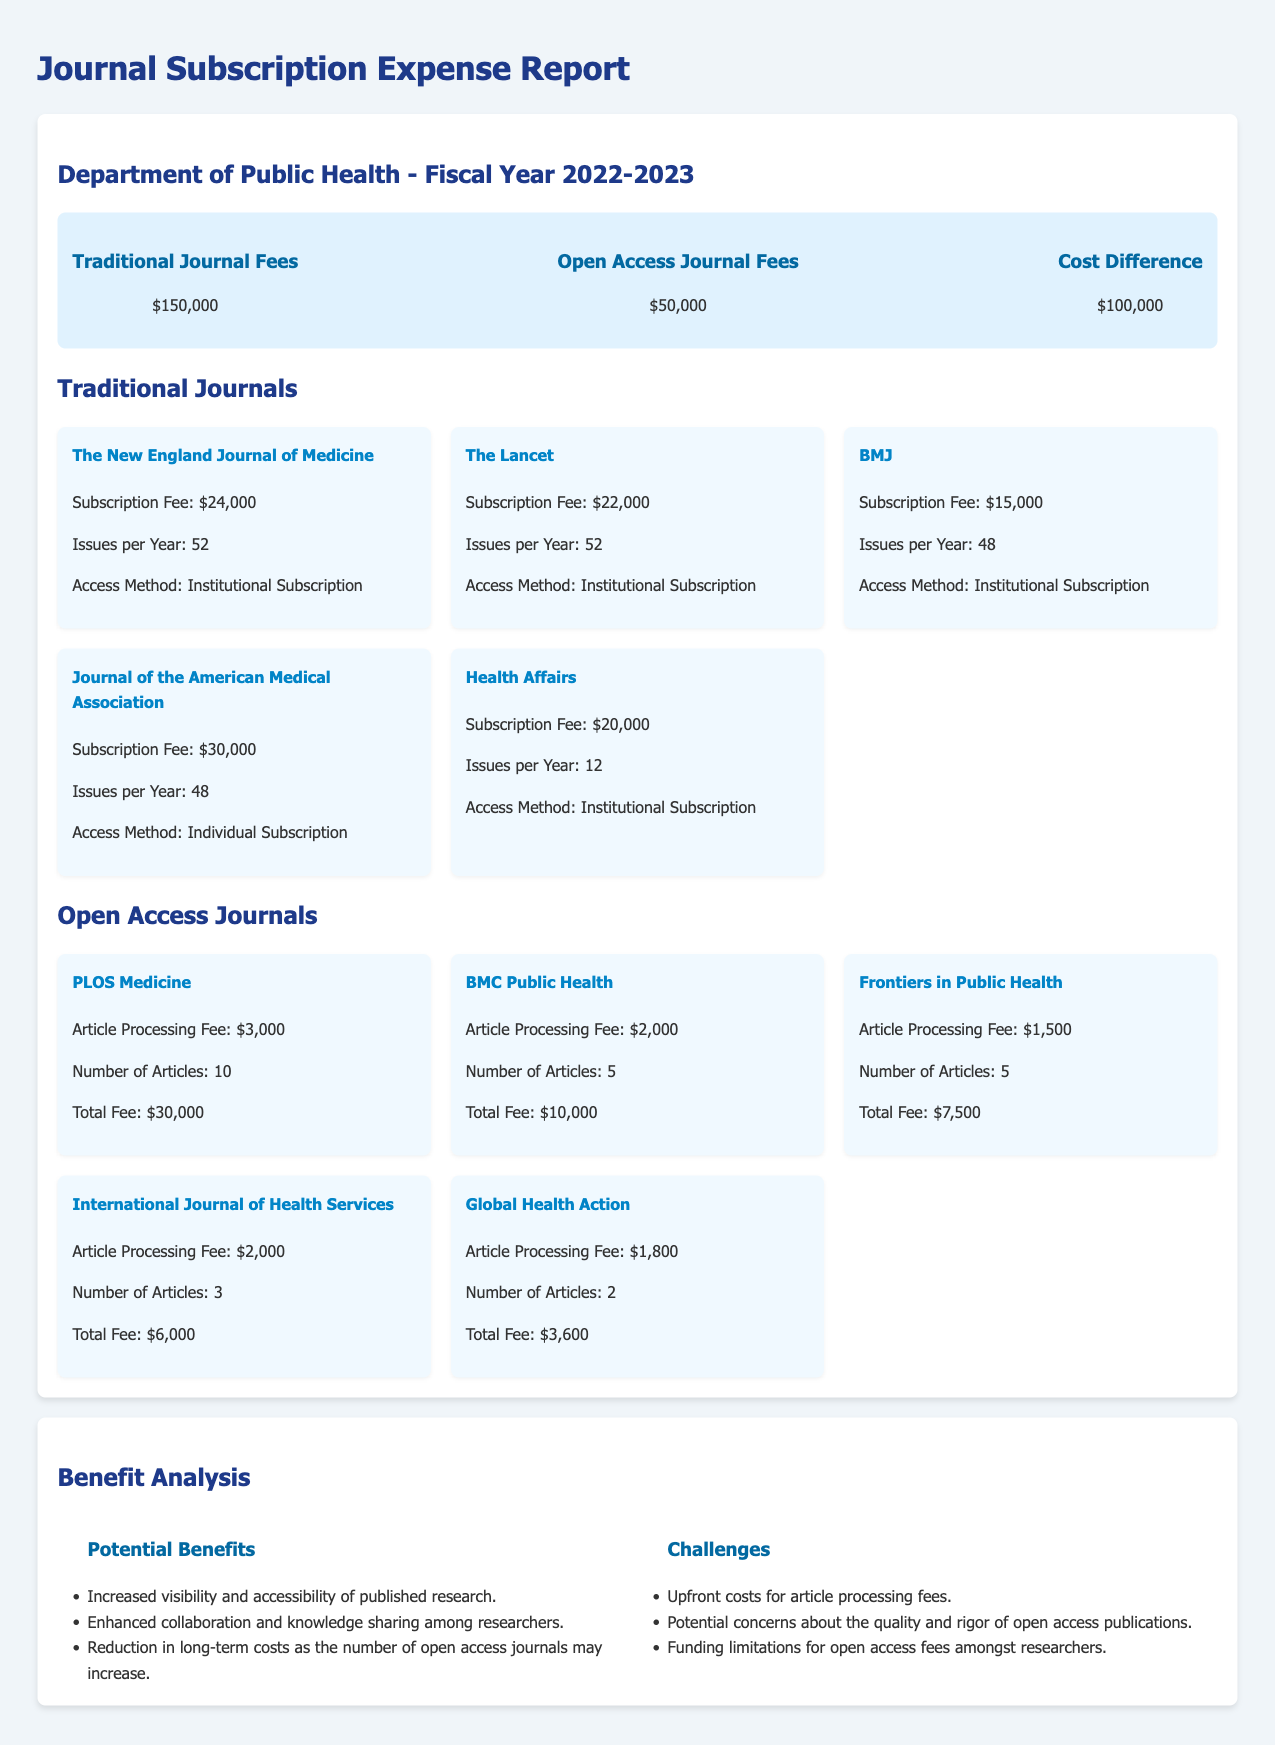What are the total traditional journal fees? The total traditional journal fees are listed in the document's summary section, which is $150,000.
Answer: $150,000 What are the total open access journal fees? The total open access journal fees are provided in the summary section, which is $50,000.
Answer: $50,000 What is the cost difference between traditional and open access journals? The cost difference is displayed in the summary as $100,000.
Answer: $100,000 Which traditional journal has the highest subscription fee? The traditional journal with the highest subscription fee is listed as Journal of the American Medical Association with a fee of $30,000.
Answer: Journal of the American Medical Association How many articles did PLOS Medicine have? The document states that PLOS Medicine had 10 articles in total.
Answer: 10 What is the article processing fee for the International Journal of Health Services? The article processing fee for the International Journal of Health Services is stated as $2,000.
Answer: $2,000 What is a potential benefit of open access journals? One potential benefit is described in the document as "Increased visibility and accessibility of published research."
Answer: Increased visibility and accessibility of published research What challenge is mentioned regarding open access policies? One challenge mentioned is "Upfront costs for article processing fees."
Answer: Upfront costs for article processing fees What is the total number of issues per year for The Lancet? The total number of issues per year for The Lancet is specified as 52 in the document.
Answer: 52 